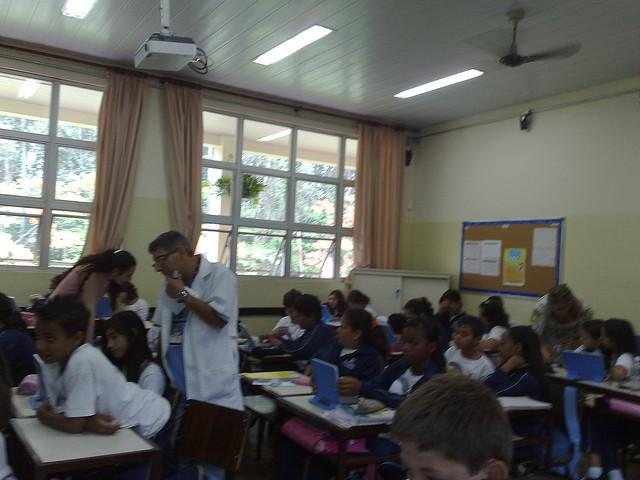What is the person in the white coat doing? Please explain your reasoning. teaching. The person is the only adult in the classroom. 